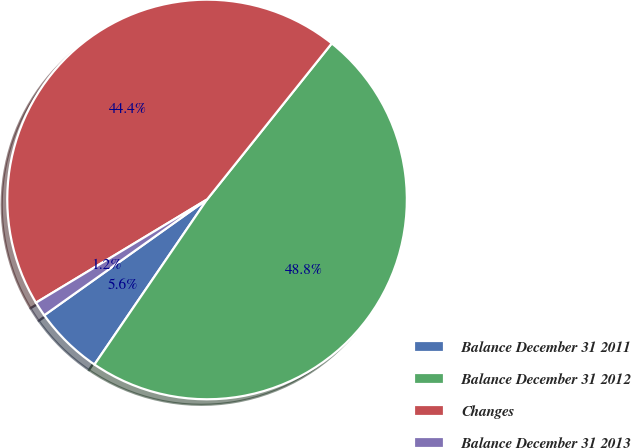Convert chart to OTSL. <chart><loc_0><loc_0><loc_500><loc_500><pie_chart><fcel>Balance December 31 2011<fcel>Balance December 31 2012<fcel>Changes<fcel>Balance December 31 2013<nl><fcel>5.63%<fcel>48.8%<fcel>44.37%<fcel>1.2%<nl></chart> 